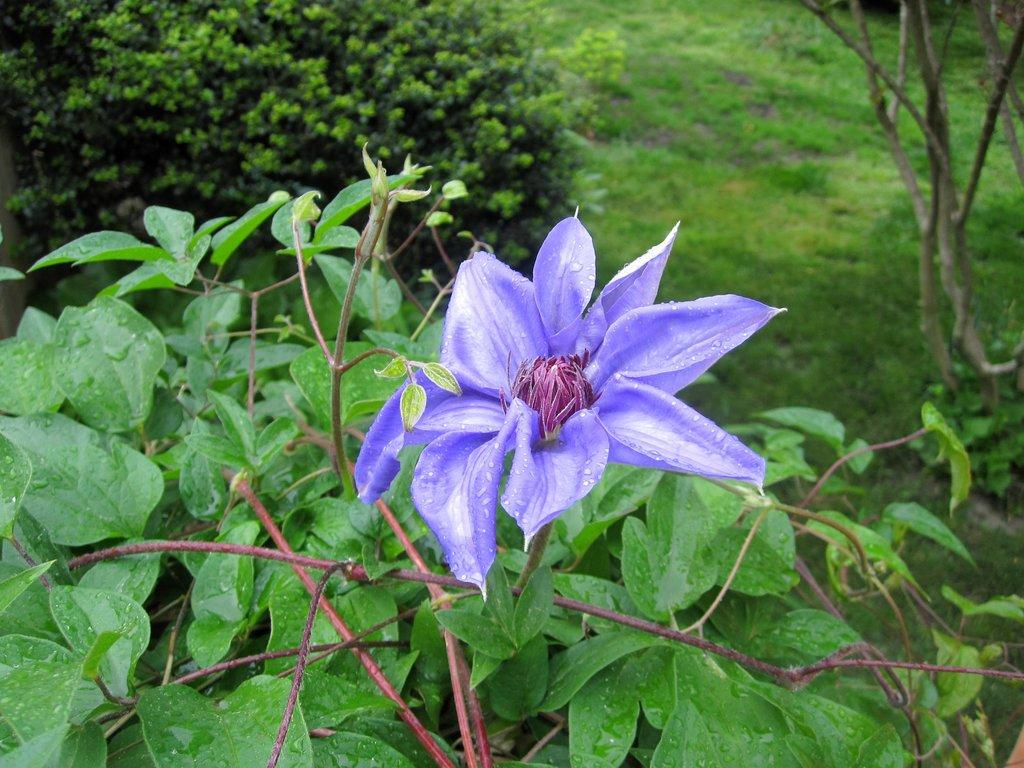What type of flowers can be seen in the image? There are purple color flowers in the image. What parts of the flowers are visible in the image? There are stems and leaves visible in the image. What is the main subject of the image? There is a plant in the image. What type of terrain is visible in the image? There is grassy land in the image. Where are the stems located in the image? There are stems at the top of the image. What type of stone treatment is being applied to the flowers in the image? There is no stone or treatment visible in the image; it features a plant with purple flowers, stems, and leaves. What discovery was made by the flowers in the image? There is no discovery being made by the flowers in the image; they are simply growing on a plant. 